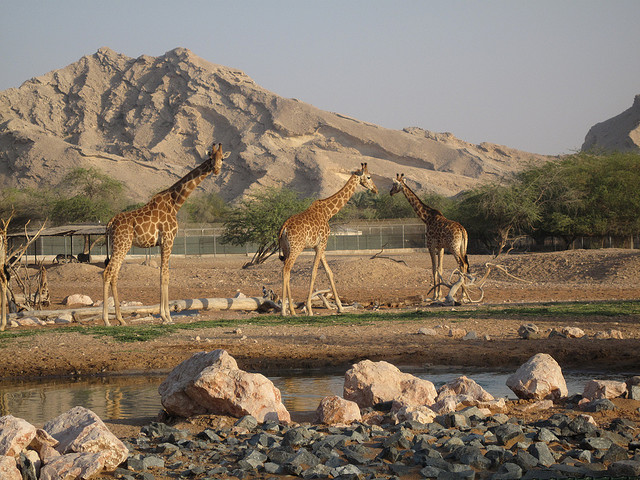<image>Is this animal alone? The animal is not alone. Is this animal alone? Based on the information provided, I cannot determine if the animal is alone or not. 